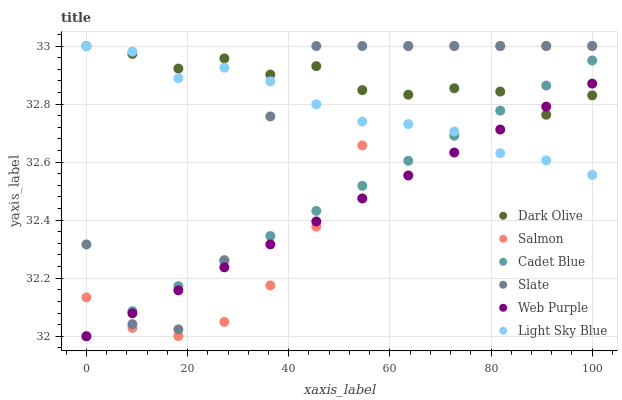Does Web Purple have the minimum area under the curve?
Answer yes or no. Yes. Does Dark Olive have the maximum area under the curve?
Answer yes or no. Yes. Does Slate have the minimum area under the curve?
Answer yes or no. No. Does Slate have the maximum area under the curve?
Answer yes or no. No. Is Web Purple the smoothest?
Answer yes or no. Yes. Is Slate the roughest?
Answer yes or no. Yes. Is Dark Olive the smoothest?
Answer yes or no. No. Is Dark Olive the roughest?
Answer yes or no. No. Does Cadet Blue have the lowest value?
Answer yes or no. Yes. Does Slate have the lowest value?
Answer yes or no. No. Does Light Sky Blue have the highest value?
Answer yes or no. Yes. Does Web Purple have the highest value?
Answer yes or no. No. Does Dark Olive intersect Slate?
Answer yes or no. Yes. Is Dark Olive less than Slate?
Answer yes or no. No. Is Dark Olive greater than Slate?
Answer yes or no. No. 